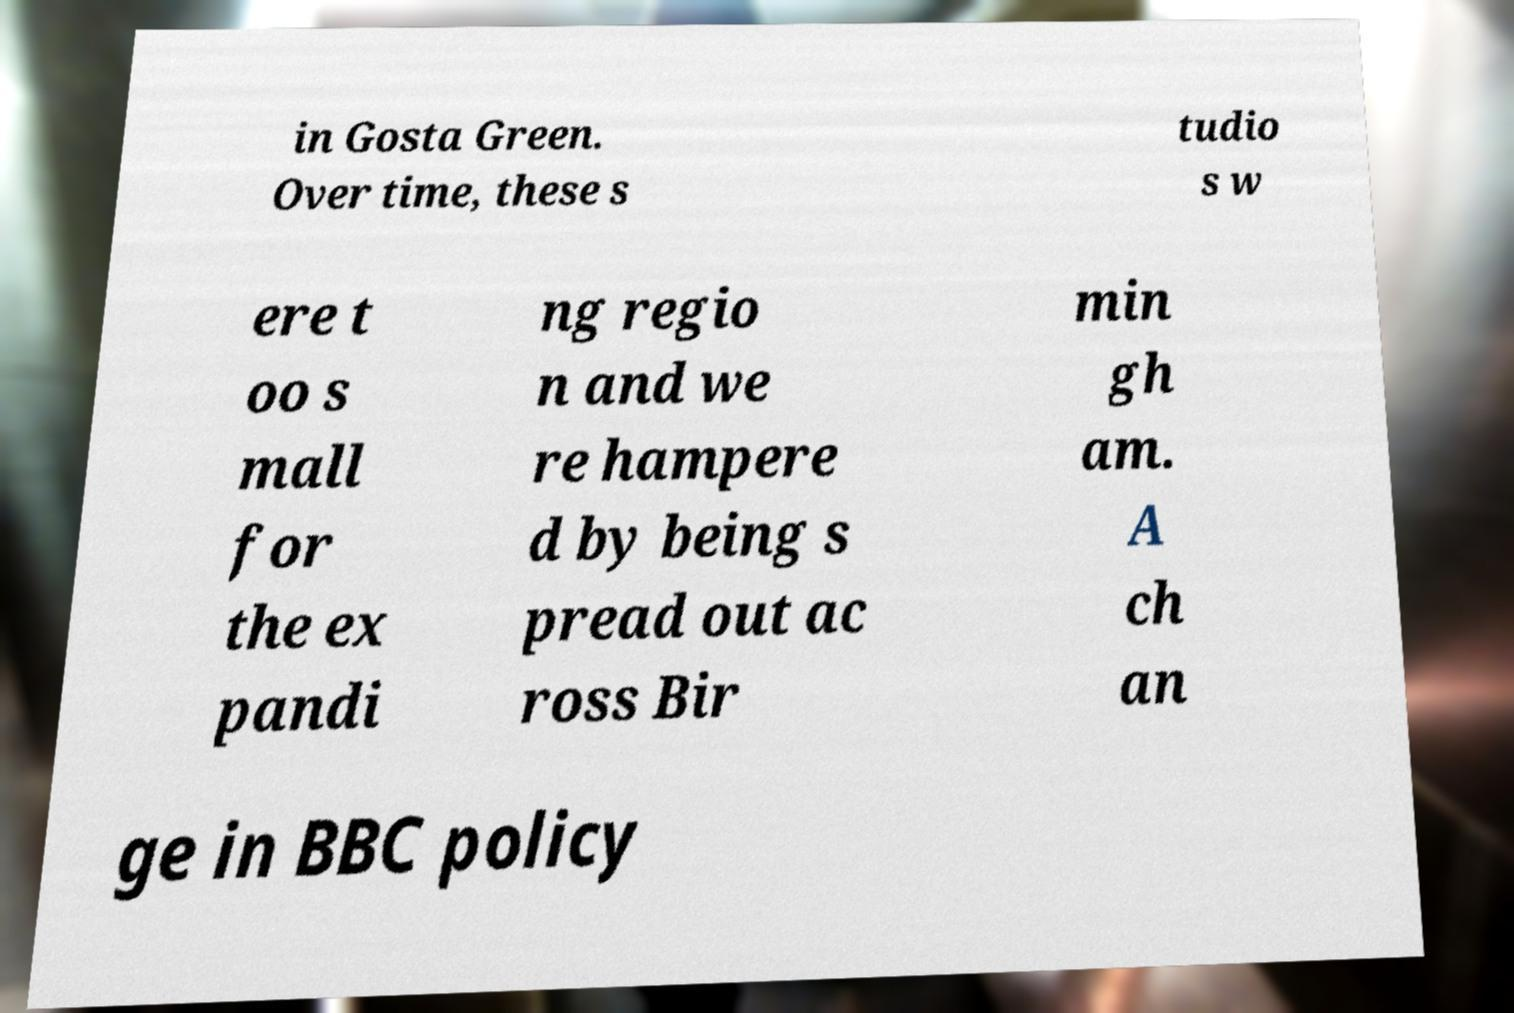Please identify and transcribe the text found in this image. in Gosta Green. Over time, these s tudio s w ere t oo s mall for the ex pandi ng regio n and we re hampere d by being s pread out ac ross Bir min gh am. A ch an ge in BBC policy 